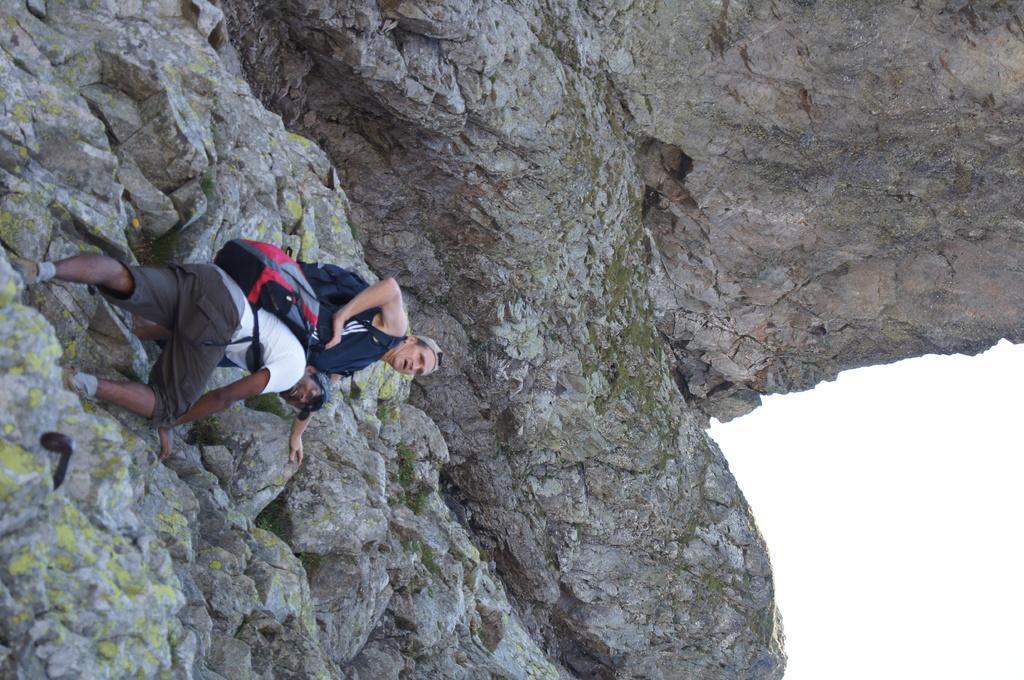In one or two sentences, can you explain what this image depicts? In this picture there are two men who are climbing a stone mountain. They are wearing the bags. In the bottom right corner I can see the sky. 